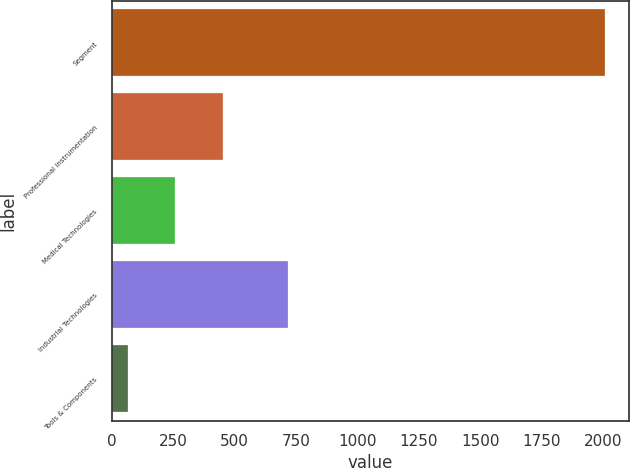Convert chart to OTSL. <chart><loc_0><loc_0><loc_500><loc_500><bar_chart><fcel>Segment<fcel>Professional Instrumentation<fcel>Medical Technologies<fcel>Industrial Technologies<fcel>Tools & Components<nl><fcel>2006<fcel>453.2<fcel>259.1<fcel>719<fcel>65<nl></chart> 